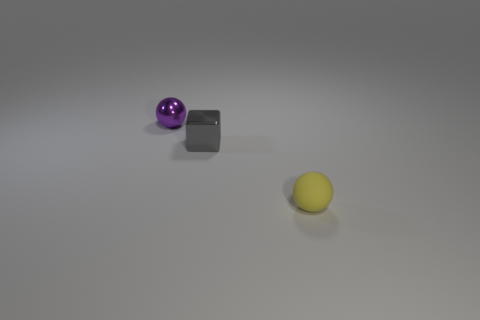What materials do the objects in the image seem to be made of? The purple sphere has a glossy finish indicative of a smooth, possibly glass-like material. The gray block appears to be metallic, given its matte texture and light reflections typical of metal surfaces. Lastly, the yellow object looks like it could be made of a matte plastic or rubber due to its opaque and even surface. 